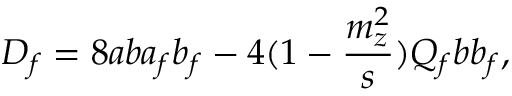Convert formula to latex. <formula><loc_0><loc_0><loc_500><loc_500>D _ { f } = 8 a b a _ { f } b _ { f } - 4 ( 1 - { \frac { m _ { z } ^ { 2 } } { s } } ) Q _ { f } b b _ { f } ,</formula> 